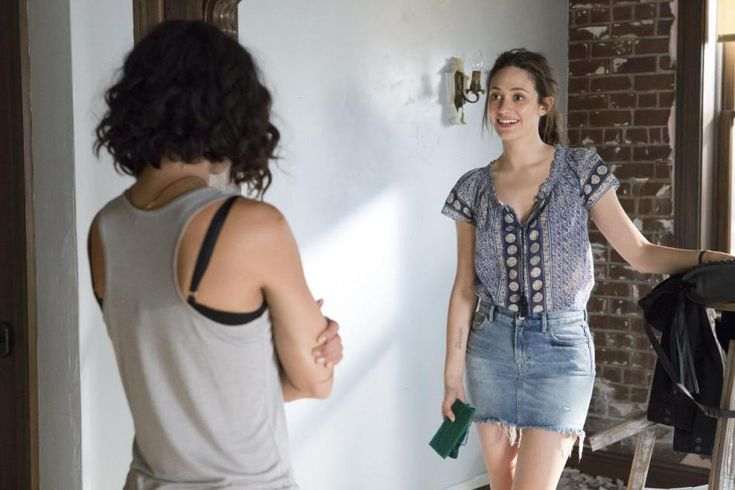What could the woman holding the green object be thinking? The woman holding the green object might be thinking about the conversation she is having with her friend. She could be contemplating something amusing or interesting that was just said, leading to her friendly and engaging expression. It’s also possible she’s planning to share something important or exciting that she’s been carrying around in the green book.  Paint a picture of the immediate future right after this moment. Right after this moment, Emma might open the green book to show Lisa its contents. They might sit down on the wooden bench, laughing and pointing at the funny pictures and stories the book holds. The warmth in the room will grow as they make plans for the weekend, maybe deciding to go out for dinner to their favorite restaurant or perhaps to the local park to enjoy the evening. This interaction is likely to strengthen their bond, leaving both of them with a sense of joy and anticipation for the times ahead. 